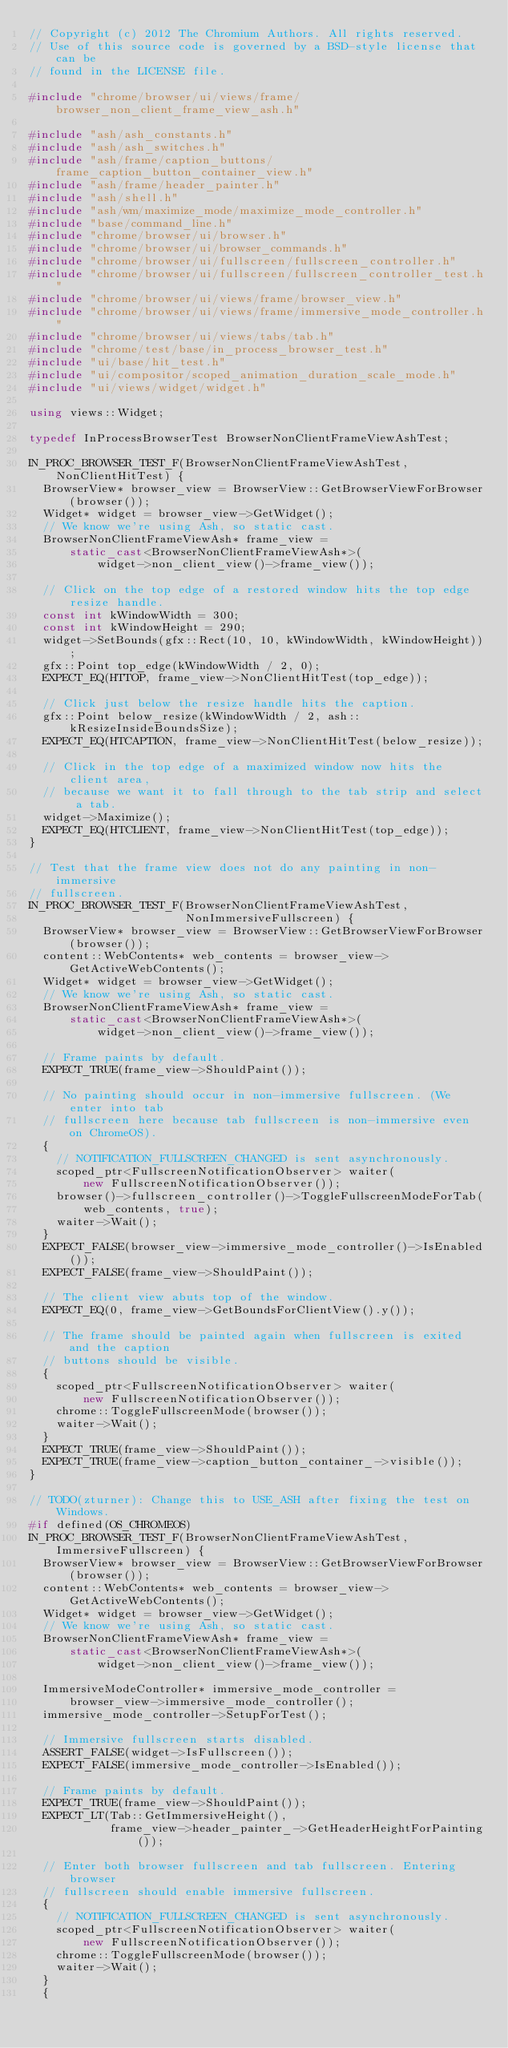<code> <loc_0><loc_0><loc_500><loc_500><_C++_>// Copyright (c) 2012 The Chromium Authors. All rights reserved.
// Use of this source code is governed by a BSD-style license that can be
// found in the LICENSE file.

#include "chrome/browser/ui/views/frame/browser_non_client_frame_view_ash.h"

#include "ash/ash_constants.h"
#include "ash/ash_switches.h"
#include "ash/frame/caption_buttons/frame_caption_button_container_view.h"
#include "ash/frame/header_painter.h"
#include "ash/shell.h"
#include "ash/wm/maximize_mode/maximize_mode_controller.h"
#include "base/command_line.h"
#include "chrome/browser/ui/browser.h"
#include "chrome/browser/ui/browser_commands.h"
#include "chrome/browser/ui/fullscreen/fullscreen_controller.h"
#include "chrome/browser/ui/fullscreen/fullscreen_controller_test.h"
#include "chrome/browser/ui/views/frame/browser_view.h"
#include "chrome/browser/ui/views/frame/immersive_mode_controller.h"
#include "chrome/browser/ui/views/tabs/tab.h"
#include "chrome/test/base/in_process_browser_test.h"
#include "ui/base/hit_test.h"
#include "ui/compositor/scoped_animation_duration_scale_mode.h"
#include "ui/views/widget/widget.h"

using views::Widget;

typedef InProcessBrowserTest BrowserNonClientFrameViewAshTest;

IN_PROC_BROWSER_TEST_F(BrowserNonClientFrameViewAshTest, NonClientHitTest) {
  BrowserView* browser_view = BrowserView::GetBrowserViewForBrowser(browser());
  Widget* widget = browser_view->GetWidget();
  // We know we're using Ash, so static cast.
  BrowserNonClientFrameViewAsh* frame_view =
      static_cast<BrowserNonClientFrameViewAsh*>(
          widget->non_client_view()->frame_view());

  // Click on the top edge of a restored window hits the top edge resize handle.
  const int kWindowWidth = 300;
  const int kWindowHeight = 290;
  widget->SetBounds(gfx::Rect(10, 10, kWindowWidth, kWindowHeight));
  gfx::Point top_edge(kWindowWidth / 2, 0);
  EXPECT_EQ(HTTOP, frame_view->NonClientHitTest(top_edge));

  // Click just below the resize handle hits the caption.
  gfx::Point below_resize(kWindowWidth / 2, ash::kResizeInsideBoundsSize);
  EXPECT_EQ(HTCAPTION, frame_view->NonClientHitTest(below_resize));

  // Click in the top edge of a maximized window now hits the client area,
  // because we want it to fall through to the tab strip and select a tab.
  widget->Maximize();
  EXPECT_EQ(HTCLIENT, frame_view->NonClientHitTest(top_edge));
}

// Test that the frame view does not do any painting in non-immersive
// fullscreen.
IN_PROC_BROWSER_TEST_F(BrowserNonClientFrameViewAshTest,
                       NonImmersiveFullscreen) {
  BrowserView* browser_view = BrowserView::GetBrowserViewForBrowser(browser());
  content::WebContents* web_contents = browser_view->GetActiveWebContents();
  Widget* widget = browser_view->GetWidget();
  // We know we're using Ash, so static cast.
  BrowserNonClientFrameViewAsh* frame_view =
      static_cast<BrowserNonClientFrameViewAsh*>(
          widget->non_client_view()->frame_view());

  // Frame paints by default.
  EXPECT_TRUE(frame_view->ShouldPaint());

  // No painting should occur in non-immersive fullscreen. (We enter into tab
  // fullscreen here because tab fullscreen is non-immersive even on ChromeOS).
  {
    // NOTIFICATION_FULLSCREEN_CHANGED is sent asynchronously.
    scoped_ptr<FullscreenNotificationObserver> waiter(
        new FullscreenNotificationObserver());
    browser()->fullscreen_controller()->ToggleFullscreenModeForTab(
        web_contents, true);
    waiter->Wait();
  }
  EXPECT_FALSE(browser_view->immersive_mode_controller()->IsEnabled());
  EXPECT_FALSE(frame_view->ShouldPaint());

  // The client view abuts top of the window.
  EXPECT_EQ(0, frame_view->GetBoundsForClientView().y());

  // The frame should be painted again when fullscreen is exited and the caption
  // buttons should be visible.
  {
    scoped_ptr<FullscreenNotificationObserver> waiter(
        new FullscreenNotificationObserver());
    chrome::ToggleFullscreenMode(browser());
    waiter->Wait();
  }
  EXPECT_TRUE(frame_view->ShouldPaint());
  EXPECT_TRUE(frame_view->caption_button_container_->visible());
}

// TODO(zturner): Change this to USE_ASH after fixing the test on Windows.
#if defined(OS_CHROMEOS)
IN_PROC_BROWSER_TEST_F(BrowserNonClientFrameViewAshTest, ImmersiveFullscreen) {
  BrowserView* browser_view = BrowserView::GetBrowserViewForBrowser(browser());
  content::WebContents* web_contents = browser_view->GetActiveWebContents();
  Widget* widget = browser_view->GetWidget();
  // We know we're using Ash, so static cast.
  BrowserNonClientFrameViewAsh* frame_view =
      static_cast<BrowserNonClientFrameViewAsh*>(
          widget->non_client_view()->frame_view());

  ImmersiveModeController* immersive_mode_controller =
      browser_view->immersive_mode_controller();
  immersive_mode_controller->SetupForTest();

  // Immersive fullscreen starts disabled.
  ASSERT_FALSE(widget->IsFullscreen());
  EXPECT_FALSE(immersive_mode_controller->IsEnabled());

  // Frame paints by default.
  EXPECT_TRUE(frame_view->ShouldPaint());
  EXPECT_LT(Tab::GetImmersiveHeight(),
            frame_view->header_painter_->GetHeaderHeightForPainting());

  // Enter both browser fullscreen and tab fullscreen. Entering browser
  // fullscreen should enable immersive fullscreen.
  {
    // NOTIFICATION_FULLSCREEN_CHANGED is sent asynchronously.
    scoped_ptr<FullscreenNotificationObserver> waiter(
        new FullscreenNotificationObserver());
    chrome::ToggleFullscreenMode(browser());
    waiter->Wait();
  }
  {</code> 